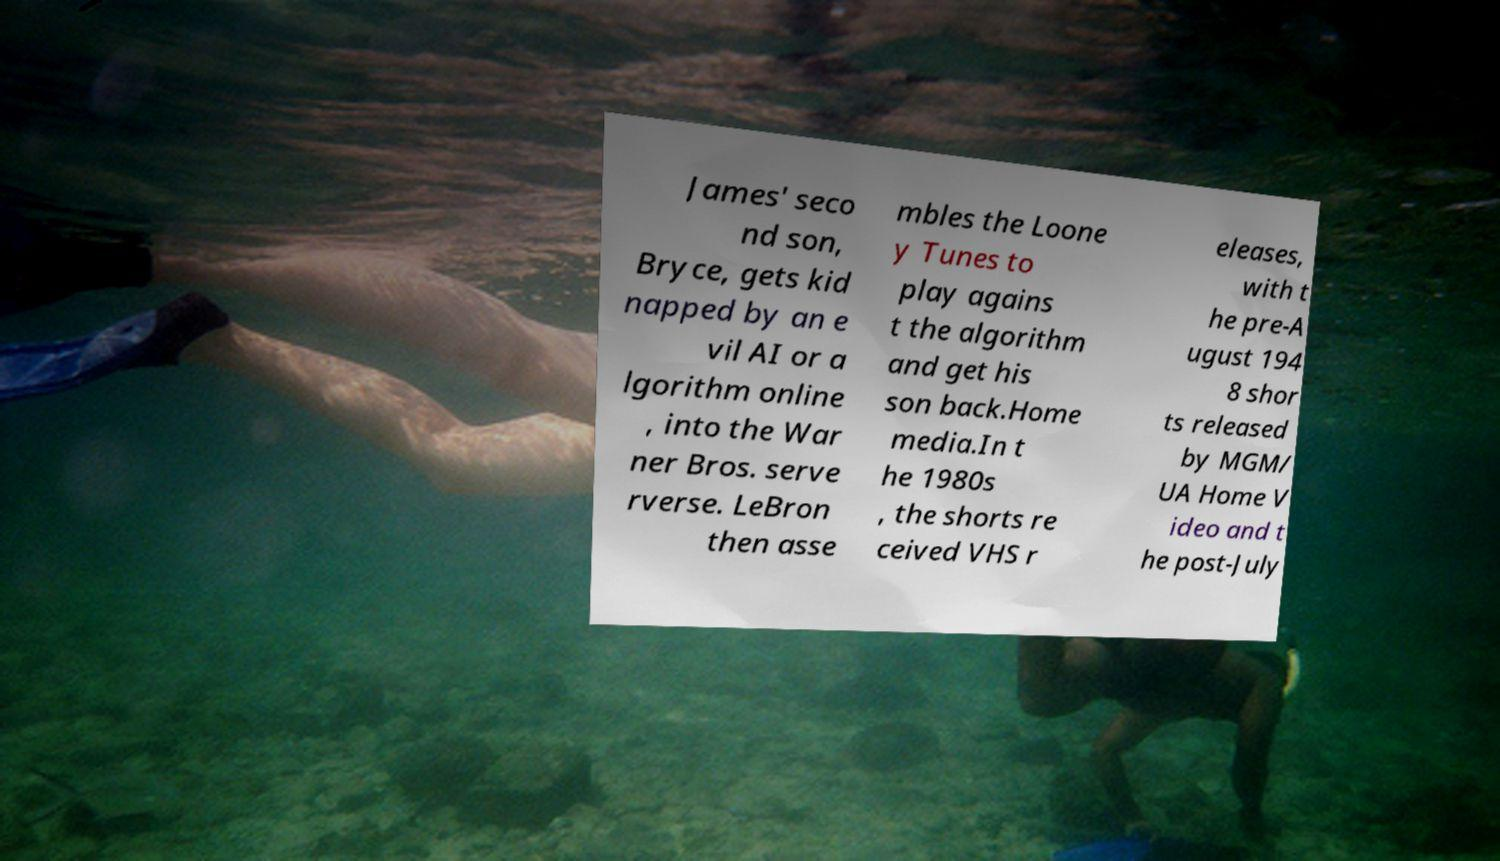What messages or text are displayed in this image? I need them in a readable, typed format. James' seco nd son, Bryce, gets kid napped by an e vil AI or a lgorithm online , into the War ner Bros. serve rverse. LeBron then asse mbles the Loone y Tunes to play agains t the algorithm and get his son back.Home media.In t he 1980s , the shorts re ceived VHS r eleases, with t he pre-A ugust 194 8 shor ts released by MGM/ UA Home V ideo and t he post-July 